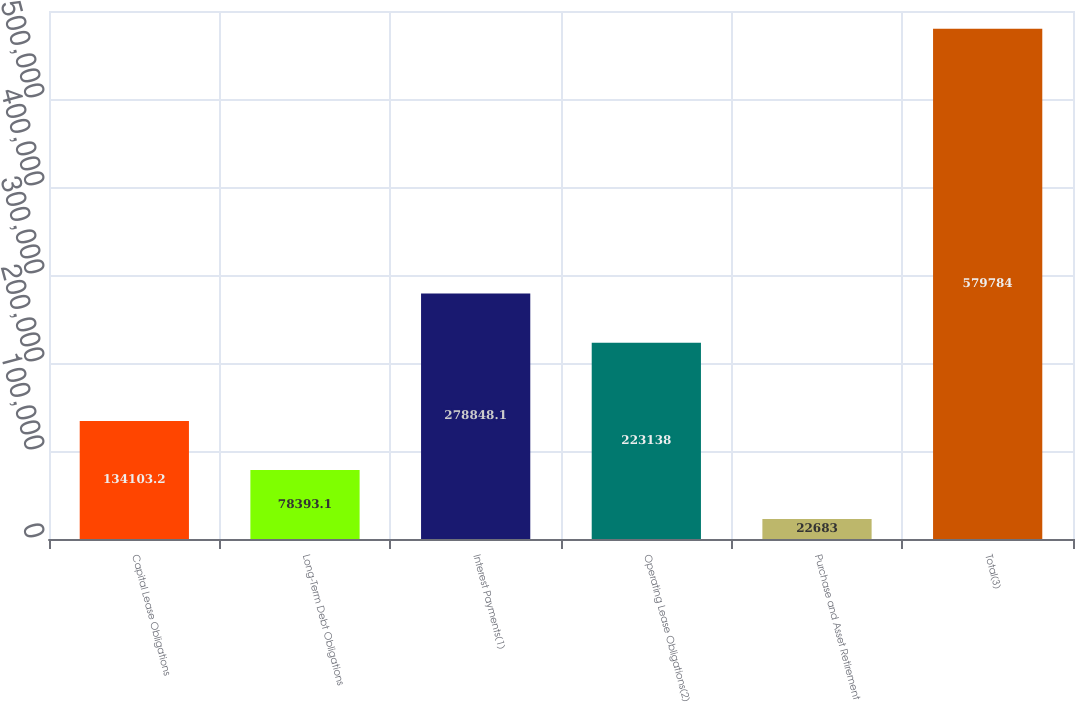Convert chart. <chart><loc_0><loc_0><loc_500><loc_500><bar_chart><fcel>Capital Lease Obligations<fcel>Long-Term Debt Obligations<fcel>Interest Payments(1)<fcel>Operating Lease Obligations(2)<fcel>Purchase and Asset Retirement<fcel>Total(3)<nl><fcel>134103<fcel>78393.1<fcel>278848<fcel>223138<fcel>22683<fcel>579784<nl></chart> 